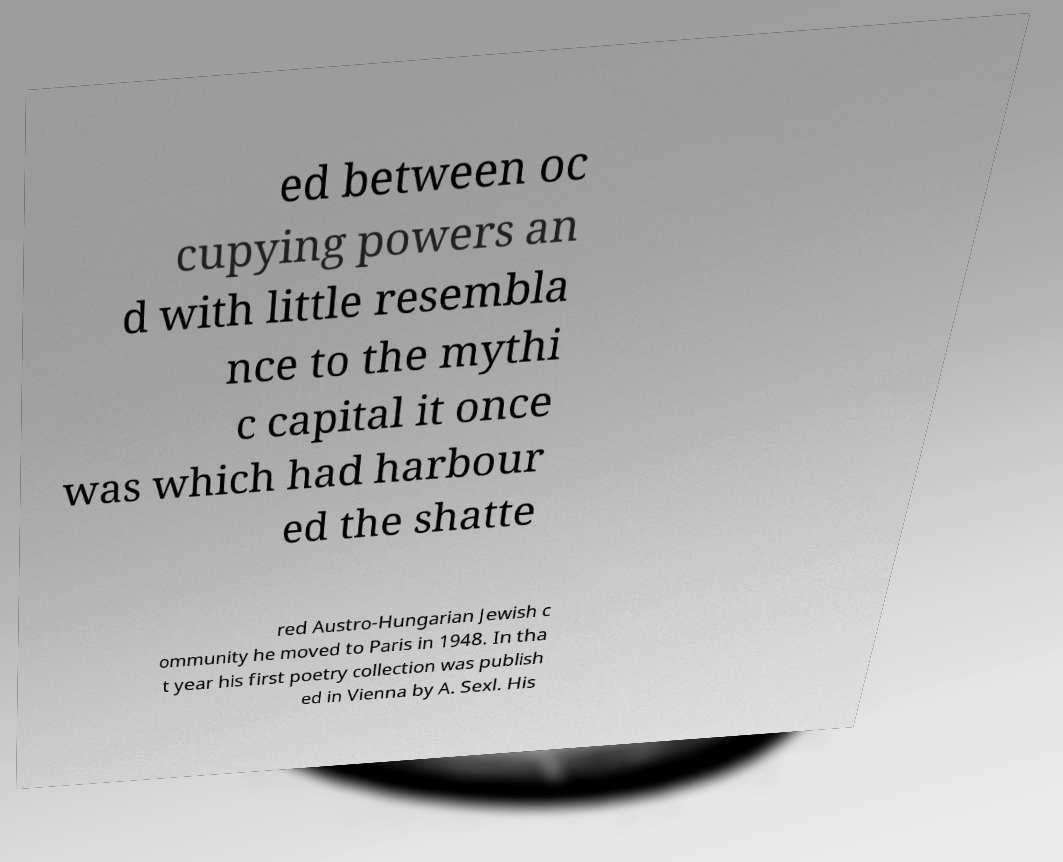Please read and relay the text visible in this image. What does it say? ed between oc cupying powers an d with little resembla nce to the mythi c capital it once was which had harbour ed the shatte red Austro-Hungarian Jewish c ommunity he moved to Paris in 1948. In tha t year his first poetry collection was publish ed in Vienna by A. Sexl. His 